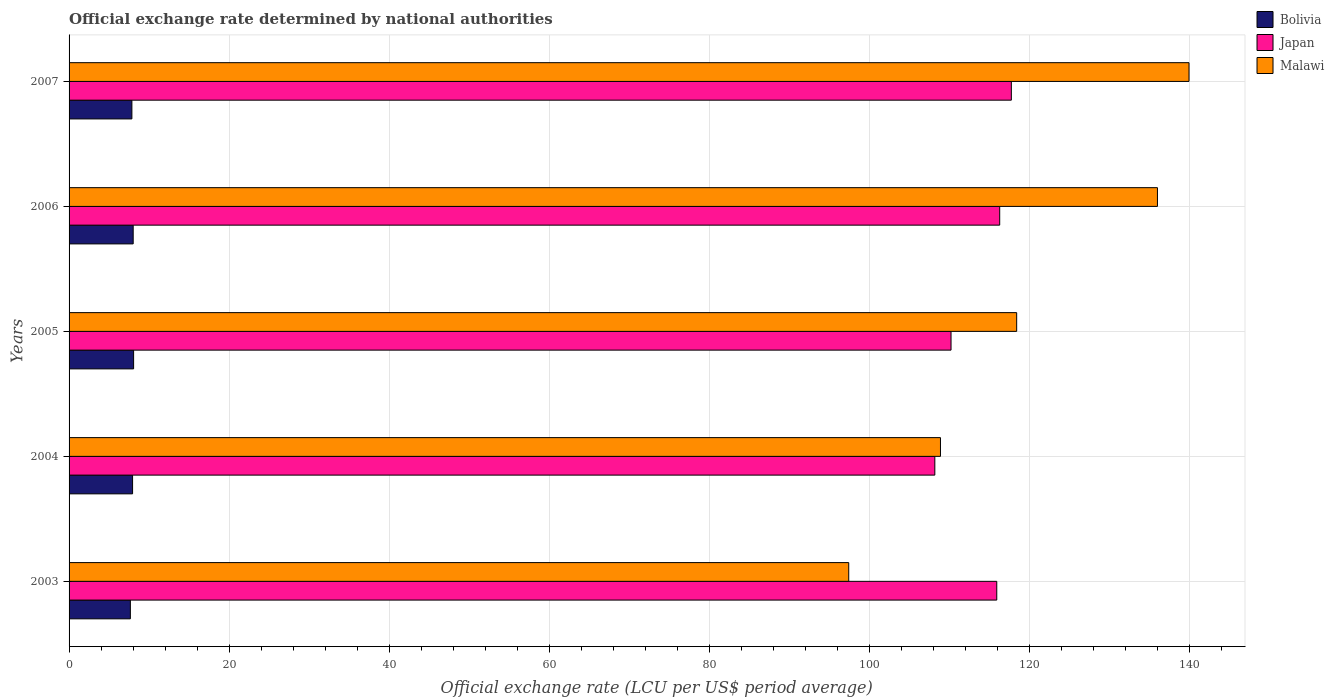How many bars are there on the 5th tick from the top?
Your answer should be very brief. 3. How many bars are there on the 1st tick from the bottom?
Your response must be concise. 3. What is the label of the 3rd group of bars from the top?
Keep it short and to the point. 2005. In how many cases, is the number of bars for a given year not equal to the number of legend labels?
Your response must be concise. 0. What is the official exchange rate in Malawi in 2006?
Offer a very short reply. 136.01. Across all years, what is the maximum official exchange rate in Japan?
Give a very brief answer. 117.75. Across all years, what is the minimum official exchange rate in Bolivia?
Your answer should be compact. 7.66. In which year was the official exchange rate in Bolivia maximum?
Provide a succinct answer. 2005. In which year was the official exchange rate in Bolivia minimum?
Offer a terse response. 2003. What is the total official exchange rate in Bolivia in the graph?
Ensure brevity in your answer.  39.52. What is the difference between the official exchange rate in Bolivia in 2003 and that in 2007?
Provide a succinct answer. -0.19. What is the difference between the official exchange rate in Bolivia in 2004 and the official exchange rate in Japan in 2007?
Provide a succinct answer. -109.82. What is the average official exchange rate in Bolivia per year?
Your answer should be compact. 7.9. In the year 2005, what is the difference between the official exchange rate in Malawi and official exchange rate in Bolivia?
Provide a short and direct response. 110.35. In how many years, is the official exchange rate in Malawi greater than 24 LCU?
Give a very brief answer. 5. What is the ratio of the official exchange rate in Japan in 2003 to that in 2004?
Offer a very short reply. 1.07. What is the difference between the highest and the second highest official exchange rate in Japan?
Your response must be concise. 1.45. What is the difference between the highest and the lowest official exchange rate in Bolivia?
Provide a short and direct response. 0.41. What does the 1st bar from the top in 2005 represents?
Provide a short and direct response. Malawi. Is it the case that in every year, the sum of the official exchange rate in Malawi and official exchange rate in Bolivia is greater than the official exchange rate in Japan?
Ensure brevity in your answer.  No. How many bars are there?
Your answer should be compact. 15. Are all the bars in the graph horizontal?
Make the answer very short. Yes. How many years are there in the graph?
Offer a terse response. 5. Are the values on the major ticks of X-axis written in scientific E-notation?
Provide a succinct answer. No. How many legend labels are there?
Your answer should be very brief. 3. How are the legend labels stacked?
Provide a succinct answer. Vertical. What is the title of the graph?
Provide a short and direct response. Official exchange rate determined by national authorities. What is the label or title of the X-axis?
Offer a very short reply. Official exchange rate (LCU per US$ period average). What is the Official exchange rate (LCU per US$ period average) in Bolivia in 2003?
Provide a succinct answer. 7.66. What is the Official exchange rate (LCU per US$ period average) of Japan in 2003?
Provide a succinct answer. 115.93. What is the Official exchange rate (LCU per US$ period average) of Malawi in 2003?
Your response must be concise. 97.43. What is the Official exchange rate (LCU per US$ period average) of Bolivia in 2004?
Offer a very short reply. 7.94. What is the Official exchange rate (LCU per US$ period average) in Japan in 2004?
Provide a short and direct response. 108.19. What is the Official exchange rate (LCU per US$ period average) in Malawi in 2004?
Your answer should be very brief. 108.9. What is the Official exchange rate (LCU per US$ period average) of Bolivia in 2005?
Ensure brevity in your answer.  8.07. What is the Official exchange rate (LCU per US$ period average) in Japan in 2005?
Offer a terse response. 110.22. What is the Official exchange rate (LCU per US$ period average) of Malawi in 2005?
Ensure brevity in your answer.  118.42. What is the Official exchange rate (LCU per US$ period average) of Bolivia in 2006?
Offer a terse response. 8.01. What is the Official exchange rate (LCU per US$ period average) of Japan in 2006?
Offer a very short reply. 116.3. What is the Official exchange rate (LCU per US$ period average) of Malawi in 2006?
Make the answer very short. 136.01. What is the Official exchange rate (LCU per US$ period average) in Bolivia in 2007?
Offer a very short reply. 7.85. What is the Official exchange rate (LCU per US$ period average) of Japan in 2007?
Give a very brief answer. 117.75. What is the Official exchange rate (LCU per US$ period average) in Malawi in 2007?
Provide a short and direct response. 139.96. Across all years, what is the maximum Official exchange rate (LCU per US$ period average) in Bolivia?
Offer a terse response. 8.07. Across all years, what is the maximum Official exchange rate (LCU per US$ period average) of Japan?
Make the answer very short. 117.75. Across all years, what is the maximum Official exchange rate (LCU per US$ period average) of Malawi?
Provide a short and direct response. 139.96. Across all years, what is the minimum Official exchange rate (LCU per US$ period average) of Bolivia?
Provide a short and direct response. 7.66. Across all years, what is the minimum Official exchange rate (LCU per US$ period average) of Japan?
Offer a terse response. 108.19. Across all years, what is the minimum Official exchange rate (LCU per US$ period average) in Malawi?
Ensure brevity in your answer.  97.43. What is the total Official exchange rate (LCU per US$ period average) in Bolivia in the graph?
Your answer should be compact. 39.52. What is the total Official exchange rate (LCU per US$ period average) of Japan in the graph?
Keep it short and to the point. 568.4. What is the total Official exchange rate (LCU per US$ period average) of Malawi in the graph?
Your answer should be compact. 600.72. What is the difference between the Official exchange rate (LCU per US$ period average) of Bolivia in 2003 and that in 2004?
Offer a very short reply. -0.28. What is the difference between the Official exchange rate (LCU per US$ period average) in Japan in 2003 and that in 2004?
Make the answer very short. 7.74. What is the difference between the Official exchange rate (LCU per US$ period average) in Malawi in 2003 and that in 2004?
Make the answer very short. -11.46. What is the difference between the Official exchange rate (LCU per US$ period average) of Bolivia in 2003 and that in 2005?
Your answer should be very brief. -0.41. What is the difference between the Official exchange rate (LCU per US$ period average) of Japan in 2003 and that in 2005?
Your response must be concise. 5.72. What is the difference between the Official exchange rate (LCU per US$ period average) in Malawi in 2003 and that in 2005?
Your response must be concise. -20.99. What is the difference between the Official exchange rate (LCU per US$ period average) of Bolivia in 2003 and that in 2006?
Your response must be concise. -0.35. What is the difference between the Official exchange rate (LCU per US$ period average) in Japan in 2003 and that in 2006?
Offer a terse response. -0.37. What is the difference between the Official exchange rate (LCU per US$ period average) in Malawi in 2003 and that in 2006?
Offer a terse response. -38.58. What is the difference between the Official exchange rate (LCU per US$ period average) of Bolivia in 2003 and that in 2007?
Your response must be concise. -0.19. What is the difference between the Official exchange rate (LCU per US$ period average) of Japan in 2003 and that in 2007?
Give a very brief answer. -1.82. What is the difference between the Official exchange rate (LCU per US$ period average) of Malawi in 2003 and that in 2007?
Your answer should be very brief. -42.52. What is the difference between the Official exchange rate (LCU per US$ period average) in Bolivia in 2004 and that in 2005?
Your answer should be compact. -0.13. What is the difference between the Official exchange rate (LCU per US$ period average) of Japan in 2004 and that in 2005?
Your answer should be very brief. -2.03. What is the difference between the Official exchange rate (LCU per US$ period average) of Malawi in 2004 and that in 2005?
Provide a short and direct response. -9.52. What is the difference between the Official exchange rate (LCU per US$ period average) in Bolivia in 2004 and that in 2006?
Give a very brief answer. -0.08. What is the difference between the Official exchange rate (LCU per US$ period average) of Japan in 2004 and that in 2006?
Offer a very short reply. -8.11. What is the difference between the Official exchange rate (LCU per US$ period average) of Malawi in 2004 and that in 2006?
Your answer should be very brief. -27.12. What is the difference between the Official exchange rate (LCU per US$ period average) in Bolivia in 2004 and that in 2007?
Provide a short and direct response. 0.09. What is the difference between the Official exchange rate (LCU per US$ period average) in Japan in 2004 and that in 2007?
Offer a terse response. -9.56. What is the difference between the Official exchange rate (LCU per US$ period average) of Malawi in 2004 and that in 2007?
Offer a terse response. -31.06. What is the difference between the Official exchange rate (LCU per US$ period average) of Bolivia in 2005 and that in 2006?
Your answer should be compact. 0.05. What is the difference between the Official exchange rate (LCU per US$ period average) of Japan in 2005 and that in 2006?
Your answer should be compact. -6.08. What is the difference between the Official exchange rate (LCU per US$ period average) of Malawi in 2005 and that in 2006?
Ensure brevity in your answer.  -17.59. What is the difference between the Official exchange rate (LCU per US$ period average) in Bolivia in 2005 and that in 2007?
Provide a short and direct response. 0.21. What is the difference between the Official exchange rate (LCU per US$ period average) in Japan in 2005 and that in 2007?
Your answer should be compact. -7.54. What is the difference between the Official exchange rate (LCU per US$ period average) of Malawi in 2005 and that in 2007?
Offer a very short reply. -21.54. What is the difference between the Official exchange rate (LCU per US$ period average) of Bolivia in 2006 and that in 2007?
Ensure brevity in your answer.  0.16. What is the difference between the Official exchange rate (LCU per US$ period average) in Japan in 2006 and that in 2007?
Offer a terse response. -1.45. What is the difference between the Official exchange rate (LCU per US$ period average) in Malawi in 2006 and that in 2007?
Your response must be concise. -3.94. What is the difference between the Official exchange rate (LCU per US$ period average) in Bolivia in 2003 and the Official exchange rate (LCU per US$ period average) in Japan in 2004?
Keep it short and to the point. -100.53. What is the difference between the Official exchange rate (LCU per US$ period average) of Bolivia in 2003 and the Official exchange rate (LCU per US$ period average) of Malawi in 2004?
Offer a terse response. -101.24. What is the difference between the Official exchange rate (LCU per US$ period average) in Japan in 2003 and the Official exchange rate (LCU per US$ period average) in Malawi in 2004?
Offer a terse response. 7.04. What is the difference between the Official exchange rate (LCU per US$ period average) of Bolivia in 2003 and the Official exchange rate (LCU per US$ period average) of Japan in 2005?
Ensure brevity in your answer.  -102.56. What is the difference between the Official exchange rate (LCU per US$ period average) of Bolivia in 2003 and the Official exchange rate (LCU per US$ period average) of Malawi in 2005?
Your response must be concise. -110.76. What is the difference between the Official exchange rate (LCU per US$ period average) of Japan in 2003 and the Official exchange rate (LCU per US$ period average) of Malawi in 2005?
Ensure brevity in your answer.  -2.49. What is the difference between the Official exchange rate (LCU per US$ period average) of Bolivia in 2003 and the Official exchange rate (LCU per US$ period average) of Japan in 2006?
Ensure brevity in your answer.  -108.64. What is the difference between the Official exchange rate (LCU per US$ period average) of Bolivia in 2003 and the Official exchange rate (LCU per US$ period average) of Malawi in 2006?
Provide a short and direct response. -128.35. What is the difference between the Official exchange rate (LCU per US$ period average) of Japan in 2003 and the Official exchange rate (LCU per US$ period average) of Malawi in 2006?
Your answer should be very brief. -20.08. What is the difference between the Official exchange rate (LCU per US$ period average) of Bolivia in 2003 and the Official exchange rate (LCU per US$ period average) of Japan in 2007?
Your answer should be compact. -110.09. What is the difference between the Official exchange rate (LCU per US$ period average) of Bolivia in 2003 and the Official exchange rate (LCU per US$ period average) of Malawi in 2007?
Make the answer very short. -132.3. What is the difference between the Official exchange rate (LCU per US$ period average) of Japan in 2003 and the Official exchange rate (LCU per US$ period average) of Malawi in 2007?
Make the answer very short. -24.02. What is the difference between the Official exchange rate (LCU per US$ period average) in Bolivia in 2004 and the Official exchange rate (LCU per US$ period average) in Japan in 2005?
Make the answer very short. -102.28. What is the difference between the Official exchange rate (LCU per US$ period average) of Bolivia in 2004 and the Official exchange rate (LCU per US$ period average) of Malawi in 2005?
Your answer should be very brief. -110.48. What is the difference between the Official exchange rate (LCU per US$ period average) in Japan in 2004 and the Official exchange rate (LCU per US$ period average) in Malawi in 2005?
Ensure brevity in your answer.  -10.23. What is the difference between the Official exchange rate (LCU per US$ period average) of Bolivia in 2004 and the Official exchange rate (LCU per US$ period average) of Japan in 2006?
Provide a succinct answer. -108.36. What is the difference between the Official exchange rate (LCU per US$ period average) in Bolivia in 2004 and the Official exchange rate (LCU per US$ period average) in Malawi in 2006?
Keep it short and to the point. -128.08. What is the difference between the Official exchange rate (LCU per US$ period average) of Japan in 2004 and the Official exchange rate (LCU per US$ period average) of Malawi in 2006?
Your answer should be compact. -27.82. What is the difference between the Official exchange rate (LCU per US$ period average) in Bolivia in 2004 and the Official exchange rate (LCU per US$ period average) in Japan in 2007?
Your answer should be compact. -109.82. What is the difference between the Official exchange rate (LCU per US$ period average) in Bolivia in 2004 and the Official exchange rate (LCU per US$ period average) in Malawi in 2007?
Offer a terse response. -132.02. What is the difference between the Official exchange rate (LCU per US$ period average) in Japan in 2004 and the Official exchange rate (LCU per US$ period average) in Malawi in 2007?
Offer a terse response. -31.76. What is the difference between the Official exchange rate (LCU per US$ period average) in Bolivia in 2005 and the Official exchange rate (LCU per US$ period average) in Japan in 2006?
Ensure brevity in your answer.  -108.23. What is the difference between the Official exchange rate (LCU per US$ period average) of Bolivia in 2005 and the Official exchange rate (LCU per US$ period average) of Malawi in 2006?
Provide a short and direct response. -127.95. What is the difference between the Official exchange rate (LCU per US$ period average) in Japan in 2005 and the Official exchange rate (LCU per US$ period average) in Malawi in 2006?
Make the answer very short. -25.8. What is the difference between the Official exchange rate (LCU per US$ period average) of Bolivia in 2005 and the Official exchange rate (LCU per US$ period average) of Japan in 2007?
Make the answer very short. -109.69. What is the difference between the Official exchange rate (LCU per US$ period average) of Bolivia in 2005 and the Official exchange rate (LCU per US$ period average) of Malawi in 2007?
Your answer should be compact. -131.89. What is the difference between the Official exchange rate (LCU per US$ period average) of Japan in 2005 and the Official exchange rate (LCU per US$ period average) of Malawi in 2007?
Offer a very short reply. -29.74. What is the difference between the Official exchange rate (LCU per US$ period average) of Bolivia in 2006 and the Official exchange rate (LCU per US$ period average) of Japan in 2007?
Offer a terse response. -109.74. What is the difference between the Official exchange rate (LCU per US$ period average) of Bolivia in 2006 and the Official exchange rate (LCU per US$ period average) of Malawi in 2007?
Keep it short and to the point. -131.95. What is the difference between the Official exchange rate (LCU per US$ period average) in Japan in 2006 and the Official exchange rate (LCU per US$ period average) in Malawi in 2007?
Offer a very short reply. -23.66. What is the average Official exchange rate (LCU per US$ period average) of Bolivia per year?
Offer a terse response. 7.9. What is the average Official exchange rate (LCU per US$ period average) in Japan per year?
Give a very brief answer. 113.68. What is the average Official exchange rate (LCU per US$ period average) in Malawi per year?
Provide a short and direct response. 120.14. In the year 2003, what is the difference between the Official exchange rate (LCU per US$ period average) of Bolivia and Official exchange rate (LCU per US$ period average) of Japan?
Your answer should be compact. -108.27. In the year 2003, what is the difference between the Official exchange rate (LCU per US$ period average) of Bolivia and Official exchange rate (LCU per US$ period average) of Malawi?
Your response must be concise. -89.77. In the year 2003, what is the difference between the Official exchange rate (LCU per US$ period average) in Japan and Official exchange rate (LCU per US$ period average) in Malawi?
Your answer should be very brief. 18.5. In the year 2004, what is the difference between the Official exchange rate (LCU per US$ period average) in Bolivia and Official exchange rate (LCU per US$ period average) in Japan?
Offer a terse response. -100.26. In the year 2004, what is the difference between the Official exchange rate (LCU per US$ period average) of Bolivia and Official exchange rate (LCU per US$ period average) of Malawi?
Make the answer very short. -100.96. In the year 2004, what is the difference between the Official exchange rate (LCU per US$ period average) of Japan and Official exchange rate (LCU per US$ period average) of Malawi?
Give a very brief answer. -0.7. In the year 2005, what is the difference between the Official exchange rate (LCU per US$ period average) of Bolivia and Official exchange rate (LCU per US$ period average) of Japan?
Your response must be concise. -102.15. In the year 2005, what is the difference between the Official exchange rate (LCU per US$ period average) of Bolivia and Official exchange rate (LCU per US$ period average) of Malawi?
Provide a short and direct response. -110.35. In the year 2005, what is the difference between the Official exchange rate (LCU per US$ period average) in Japan and Official exchange rate (LCU per US$ period average) in Malawi?
Make the answer very short. -8.2. In the year 2006, what is the difference between the Official exchange rate (LCU per US$ period average) in Bolivia and Official exchange rate (LCU per US$ period average) in Japan?
Make the answer very short. -108.29. In the year 2006, what is the difference between the Official exchange rate (LCU per US$ period average) in Bolivia and Official exchange rate (LCU per US$ period average) in Malawi?
Provide a short and direct response. -128. In the year 2006, what is the difference between the Official exchange rate (LCU per US$ period average) of Japan and Official exchange rate (LCU per US$ period average) of Malawi?
Offer a very short reply. -19.71. In the year 2007, what is the difference between the Official exchange rate (LCU per US$ period average) of Bolivia and Official exchange rate (LCU per US$ period average) of Japan?
Your response must be concise. -109.9. In the year 2007, what is the difference between the Official exchange rate (LCU per US$ period average) of Bolivia and Official exchange rate (LCU per US$ period average) of Malawi?
Your answer should be compact. -132.11. In the year 2007, what is the difference between the Official exchange rate (LCU per US$ period average) of Japan and Official exchange rate (LCU per US$ period average) of Malawi?
Provide a short and direct response. -22.2. What is the ratio of the Official exchange rate (LCU per US$ period average) in Bolivia in 2003 to that in 2004?
Your response must be concise. 0.97. What is the ratio of the Official exchange rate (LCU per US$ period average) in Japan in 2003 to that in 2004?
Offer a very short reply. 1.07. What is the ratio of the Official exchange rate (LCU per US$ period average) in Malawi in 2003 to that in 2004?
Make the answer very short. 0.89. What is the ratio of the Official exchange rate (LCU per US$ period average) in Bolivia in 2003 to that in 2005?
Your answer should be compact. 0.95. What is the ratio of the Official exchange rate (LCU per US$ period average) of Japan in 2003 to that in 2005?
Offer a terse response. 1.05. What is the ratio of the Official exchange rate (LCU per US$ period average) of Malawi in 2003 to that in 2005?
Offer a terse response. 0.82. What is the ratio of the Official exchange rate (LCU per US$ period average) of Bolivia in 2003 to that in 2006?
Offer a very short reply. 0.96. What is the ratio of the Official exchange rate (LCU per US$ period average) in Japan in 2003 to that in 2006?
Make the answer very short. 1. What is the ratio of the Official exchange rate (LCU per US$ period average) in Malawi in 2003 to that in 2006?
Provide a succinct answer. 0.72. What is the ratio of the Official exchange rate (LCU per US$ period average) in Bolivia in 2003 to that in 2007?
Ensure brevity in your answer.  0.98. What is the ratio of the Official exchange rate (LCU per US$ period average) in Japan in 2003 to that in 2007?
Your response must be concise. 0.98. What is the ratio of the Official exchange rate (LCU per US$ period average) in Malawi in 2003 to that in 2007?
Offer a very short reply. 0.7. What is the ratio of the Official exchange rate (LCU per US$ period average) in Bolivia in 2004 to that in 2005?
Ensure brevity in your answer.  0.98. What is the ratio of the Official exchange rate (LCU per US$ period average) in Japan in 2004 to that in 2005?
Your answer should be very brief. 0.98. What is the ratio of the Official exchange rate (LCU per US$ period average) in Malawi in 2004 to that in 2005?
Provide a short and direct response. 0.92. What is the ratio of the Official exchange rate (LCU per US$ period average) of Bolivia in 2004 to that in 2006?
Keep it short and to the point. 0.99. What is the ratio of the Official exchange rate (LCU per US$ period average) of Japan in 2004 to that in 2006?
Provide a short and direct response. 0.93. What is the ratio of the Official exchange rate (LCU per US$ period average) in Malawi in 2004 to that in 2006?
Keep it short and to the point. 0.8. What is the ratio of the Official exchange rate (LCU per US$ period average) in Bolivia in 2004 to that in 2007?
Ensure brevity in your answer.  1.01. What is the ratio of the Official exchange rate (LCU per US$ period average) of Japan in 2004 to that in 2007?
Offer a terse response. 0.92. What is the ratio of the Official exchange rate (LCU per US$ period average) in Malawi in 2004 to that in 2007?
Your response must be concise. 0.78. What is the ratio of the Official exchange rate (LCU per US$ period average) of Bolivia in 2005 to that in 2006?
Offer a very short reply. 1.01. What is the ratio of the Official exchange rate (LCU per US$ period average) of Japan in 2005 to that in 2006?
Give a very brief answer. 0.95. What is the ratio of the Official exchange rate (LCU per US$ period average) in Malawi in 2005 to that in 2006?
Your answer should be very brief. 0.87. What is the ratio of the Official exchange rate (LCU per US$ period average) of Bolivia in 2005 to that in 2007?
Give a very brief answer. 1.03. What is the ratio of the Official exchange rate (LCU per US$ period average) of Japan in 2005 to that in 2007?
Make the answer very short. 0.94. What is the ratio of the Official exchange rate (LCU per US$ period average) of Malawi in 2005 to that in 2007?
Make the answer very short. 0.85. What is the ratio of the Official exchange rate (LCU per US$ period average) of Bolivia in 2006 to that in 2007?
Your response must be concise. 1.02. What is the ratio of the Official exchange rate (LCU per US$ period average) in Malawi in 2006 to that in 2007?
Your answer should be very brief. 0.97. What is the difference between the highest and the second highest Official exchange rate (LCU per US$ period average) in Bolivia?
Your answer should be compact. 0.05. What is the difference between the highest and the second highest Official exchange rate (LCU per US$ period average) in Japan?
Your answer should be very brief. 1.45. What is the difference between the highest and the second highest Official exchange rate (LCU per US$ period average) of Malawi?
Your answer should be compact. 3.94. What is the difference between the highest and the lowest Official exchange rate (LCU per US$ period average) in Bolivia?
Offer a terse response. 0.41. What is the difference between the highest and the lowest Official exchange rate (LCU per US$ period average) of Japan?
Offer a terse response. 9.56. What is the difference between the highest and the lowest Official exchange rate (LCU per US$ period average) of Malawi?
Make the answer very short. 42.52. 